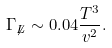Convert formula to latex. <formula><loc_0><loc_0><loc_500><loc_500>\Gamma _ { \not { L } } \sim 0 . 0 4 \frac { T ^ { 3 } } { v ^ { 2 } } .</formula> 